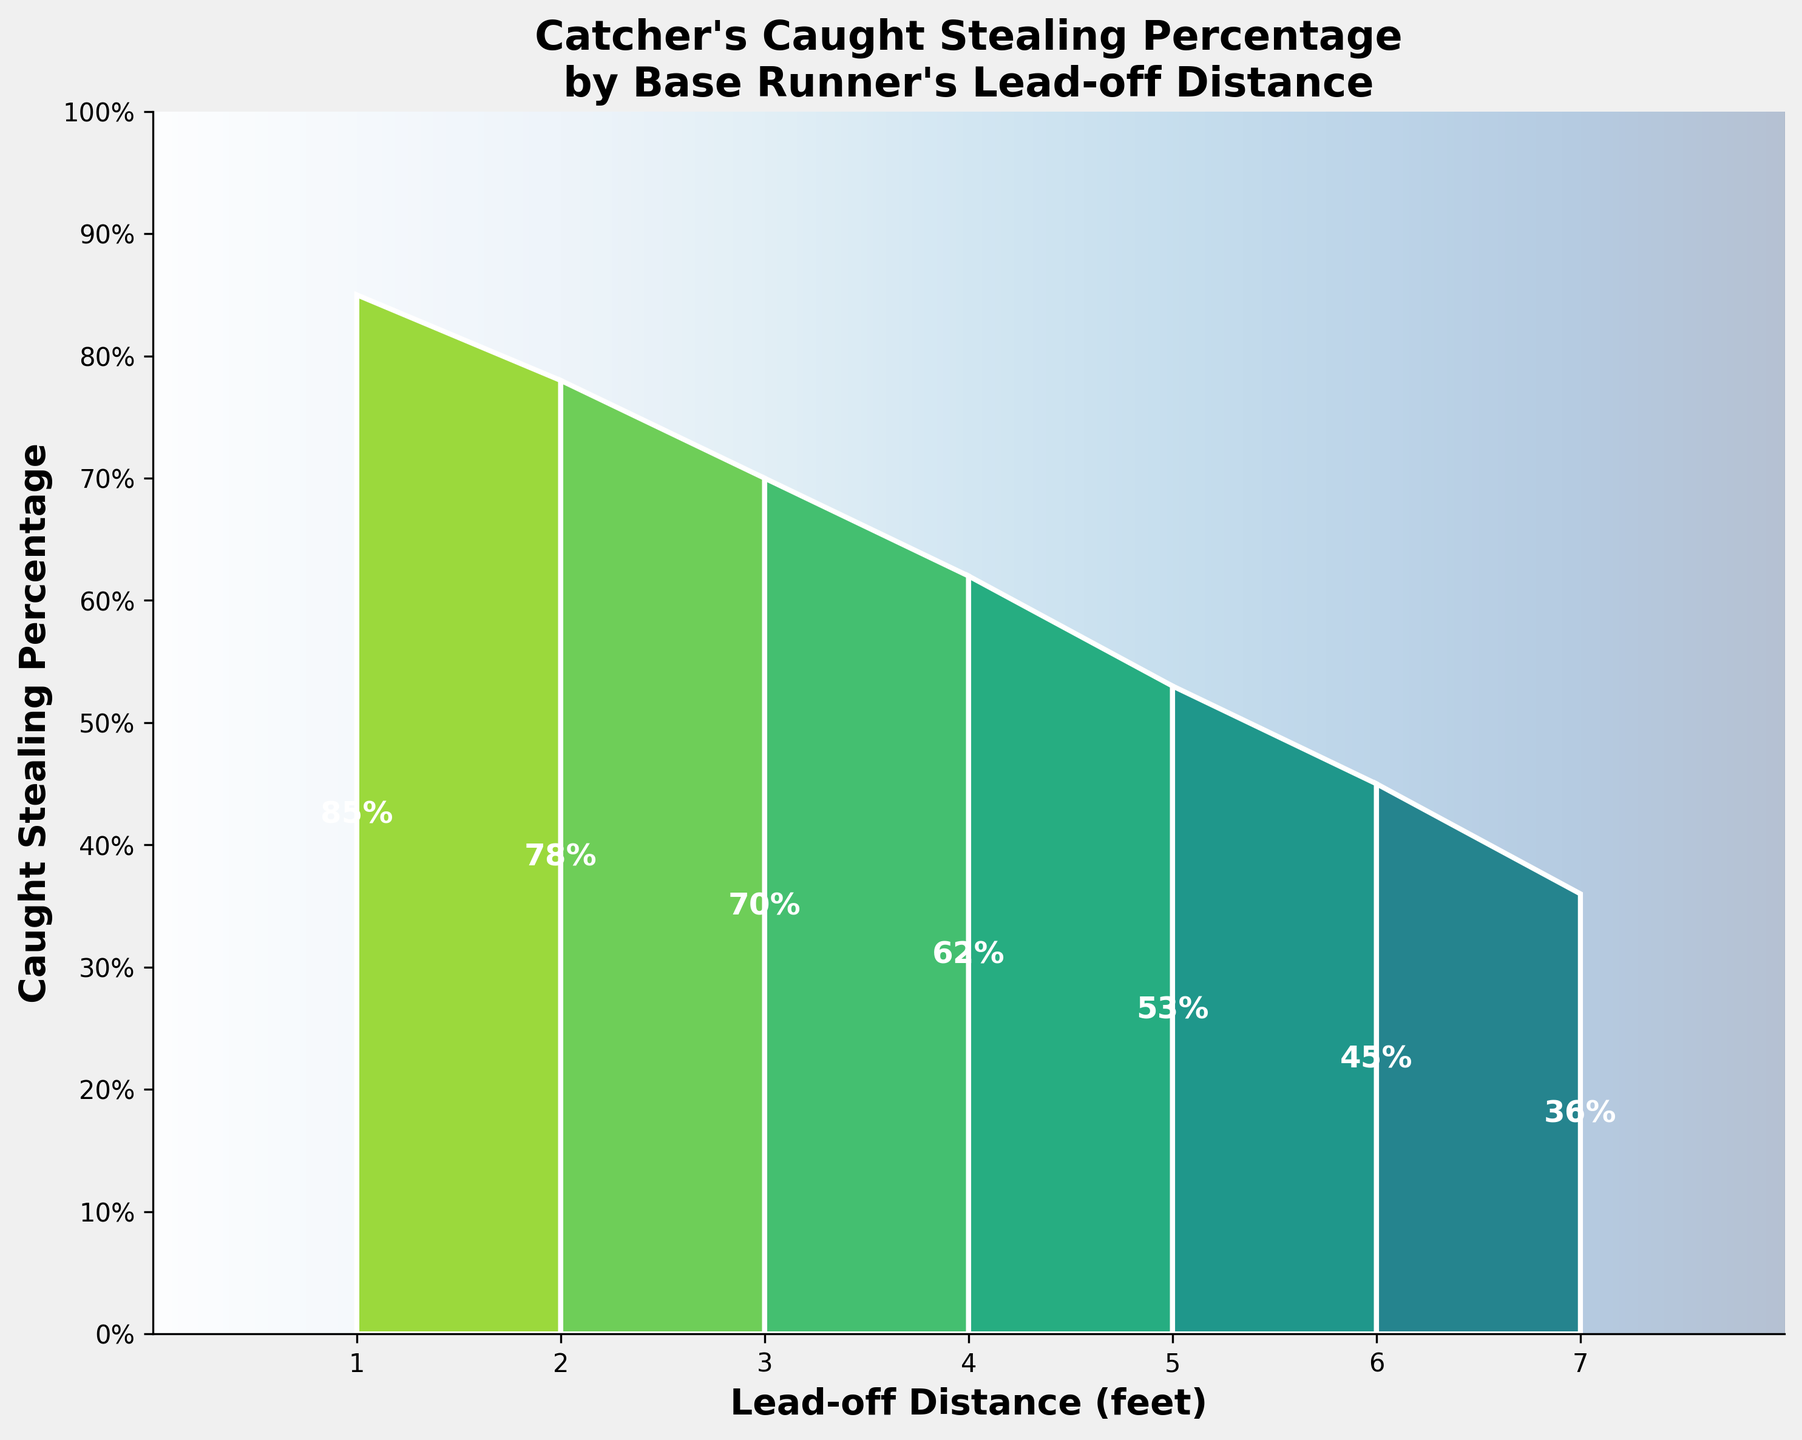What's the title of the chart? The title of the chart is typically displayed at the top of the figure; it summarizes the main content of the chart. In this case, the title is "Catcher's Caught Stealing Percentage by Base Runner's Lead-off Distance".
Answer: Catcher's Caught Stealing Percentage by Base Runner's Lead-off Distance What are the x-axis label and y-axis label? The x-axis label displays the metric for the horizontal axis, and the y-axis label displays the metric for the vertical axis. For this chart, the x-axis label is "Lead-off Distance (feet)" and the y-axis label is "Caught Stealing Percentage".
Answer: x-axis: Lead-off Distance (feet), y-axis: Caught Stealing Percentage How many distinct lead-off distances are plotted? The distinct lead-off distances shown on the x-axis indicate the number of data points, which can be counted. In this chart, the lead-off distances range from 1 to 7 feet.
Answer: 7 What is the caught stealing percentage for a lead-off distance of 4 feet? Locate the 4 feet point on the x-axis and refer up to the corresponding percentage value on the y-axis. For a lead-off distance of 4 feet, the caught stealing percentage is 62%.
Answer: 62% Which lead-off distance has the highest caught stealing percentage? To determine which lead-off distance has the highest percentage, look at the peak percentage value on the funnel chart. The highest caught stealing percentage occurs at the shortest lead-off distance of 1 foot with 85%.
Answer: 1 foot How does the caught stealing percentage change with increasing lead-off distances? Observe the general trend of the caught stealing percentages along the x-axis. The percentages decrease as the lead-off distance increases, starting at 85% for 1 foot and going down to 36% for 7 feet.
Answer: Decreases What's the average caught stealing percentage for lead-off distances of 2, 3, and 4 feet? Sum the percentages for the lead-off distances of 2, 3, and 4 feet, then divide by the number of these distances. The percentages are 78%, 70%, and 62%, respectively. (78 + 70 + 62) / 3 = 210 / 3 = 70%.
Answer: 70% At what lead-off distance does the caught stealing percentage drop below 50%? Identify when the caught stealing percentage first drops below 50% on the y-axis corresponding to the x-axis. It drops below 50% at a lead-off distance of 6 feet.
Answer: 6 feet Compare the caught stealing percentage at 3 feet and 6 feet. Check the caught stealing percentages at the lead-off distances of 3 feet and 6 feet on the chart. At 3 feet, it is 70%, and at 6 feet, it is 45%. The percentage is higher at 3 feet.
Answer: Higher at 3 feet (70% vs. 45%) If a base runner increases their lead-off distance from 5 feet to 7 feet, by what percentage does the caught stealing percentage decrease? The caught stealing percentage at 5 feet is 53% and at 7 feet is 36%. The decrease is 53% - 36% = 17%.
Answer: 17% 